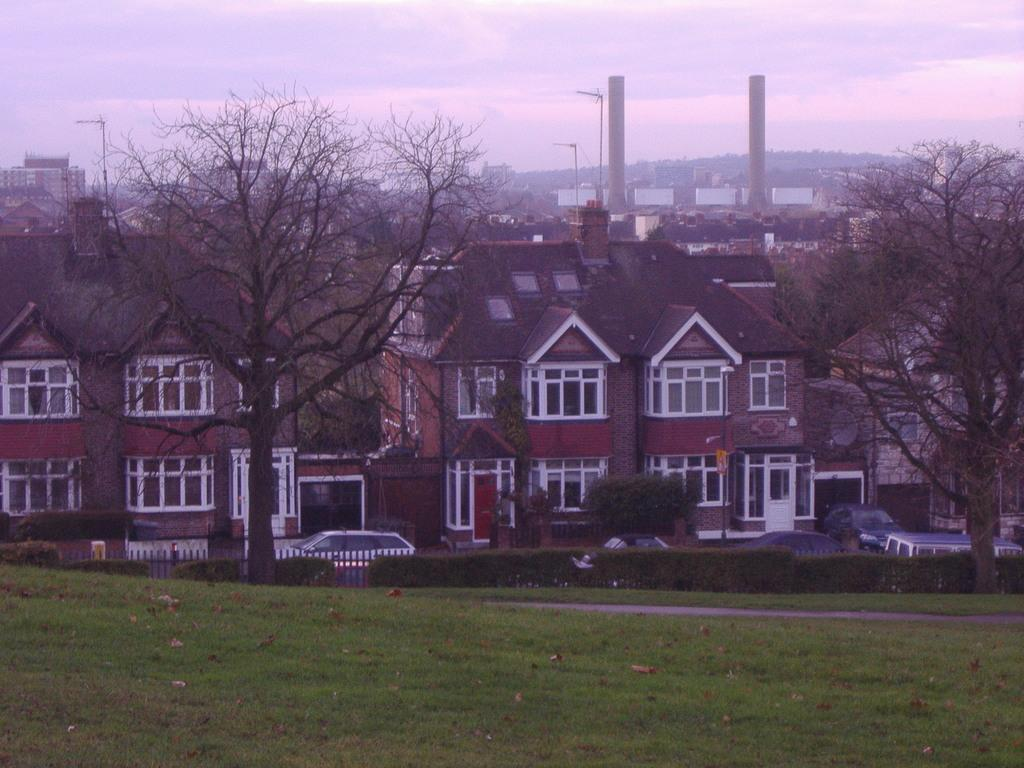What type of structures are visible in the image? There are buildings with windows in the image. What type of vegetation can be seen in the image? There are trees, bushes, and grass in the image. What type of transportation is present in the image? There are vehicles in the image. What type of tall structures are visible in the image? There are towers in the image. What part of the natural environment is visible in the image? The sky is visible in the image. What type of beef is being served at the window in the image? There is no beef or window present in the image. How many elbows can be seen in the image? There are no elbows visible in the image. 